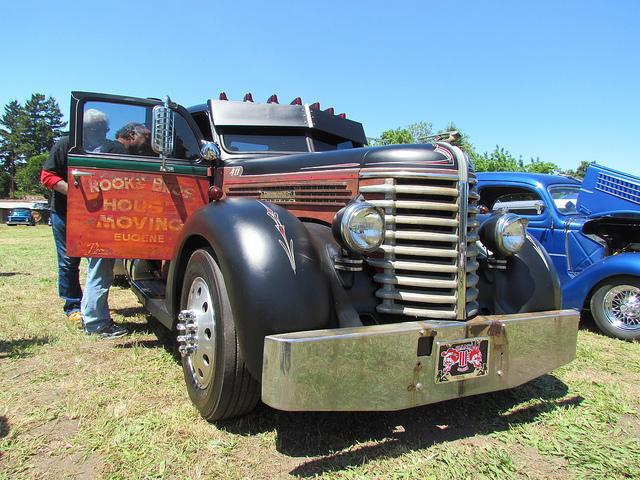These types of vehicles are commonly referred to as what?

Choices:
A) modern
B) vintage
C) contemporary
D) futuristic vintage 